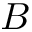Convert formula to latex. <formula><loc_0><loc_0><loc_500><loc_500>B</formula> 